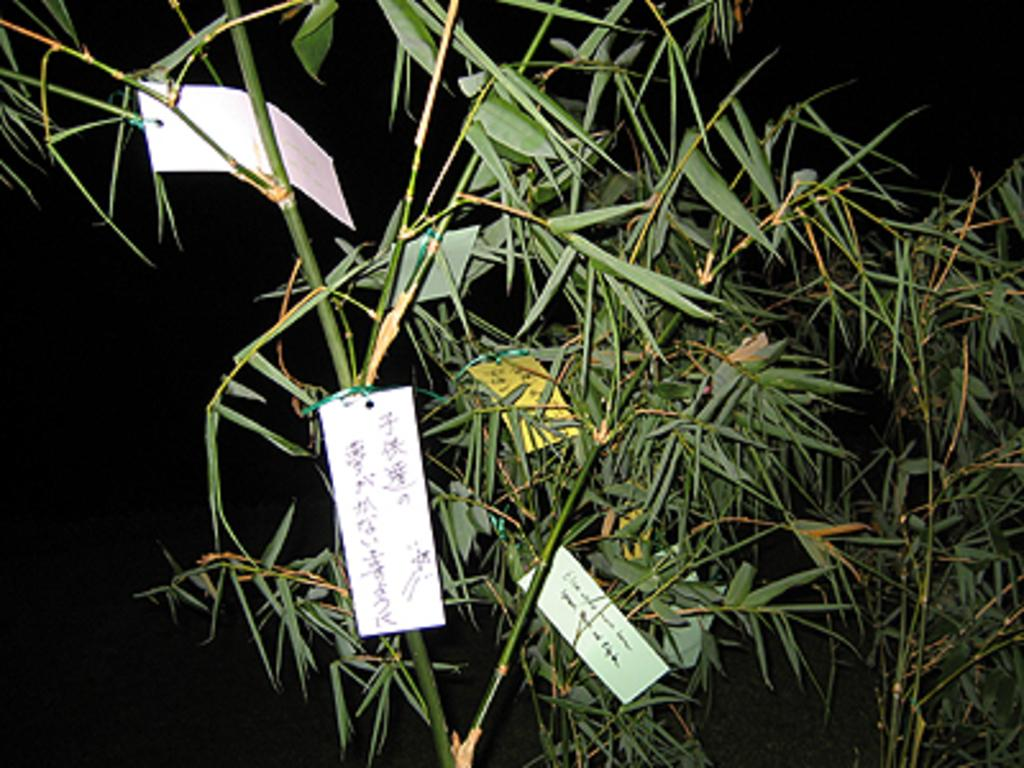What objects are placed on the plant in the image? There are cards on a plant in the image. What color is the background of the image? The background of the image is black. How many houses can be seen in the image? There are no houses present in the image; it features cards on a plant with a black background. What do you believe the cards represent in the image? The purpose or meaning of the cards in the image cannot be determined from the provided facts. 